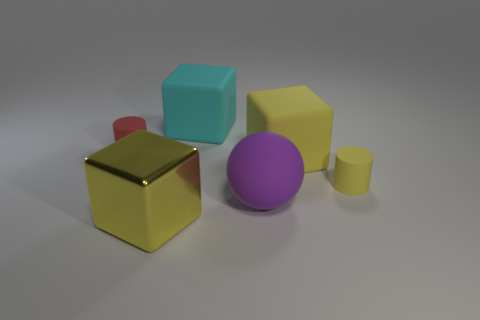Can you describe the lighting and shadows in the scene? The image displays soft lighting, casting diffuse shadows on the ground beneath each object. This suggests an evenly distributed light source, possibly from above. The shadows are soft-edged and elongated, but not excessively dark, contributing to a calm and balanced atmosphere in the scene. How does the lighting affect the perception of the objects? The gentle lighting helps to pronounce the shapes and textures of the objects without creating harsh highlights or shadows. It emphasizes the material qualities, such as the shininess of the gold cube and the matte finishes of the other shapes. Moreover, the softness of the shadows helps maintain focus on the objects themselves, providing a clear distinction between each one's position in the space. 